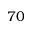Convert formula to latex. <formula><loc_0><loc_0><loc_500><loc_500>7 0</formula> 